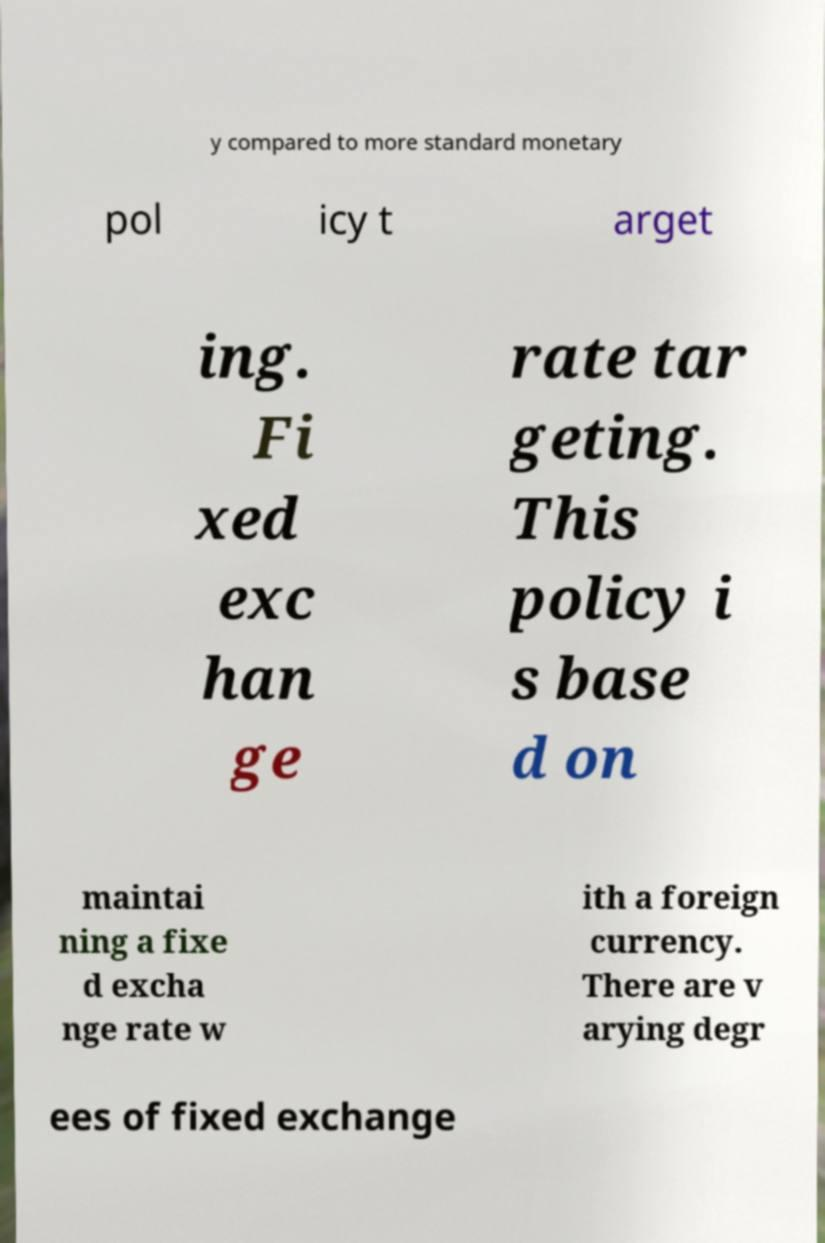Could you assist in decoding the text presented in this image and type it out clearly? y compared to more standard monetary pol icy t arget ing. Fi xed exc han ge rate tar geting. This policy i s base d on maintai ning a fixe d excha nge rate w ith a foreign currency. There are v arying degr ees of fixed exchange 